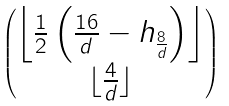<formula> <loc_0><loc_0><loc_500><loc_500>\begin{pmatrix} \left \lfloor \frac { 1 } { 2 } \left ( \frac { 1 6 } { d } - h _ { \frac { 8 } { d } } \right ) \right \rfloor \\ \lfloor \frac { 4 } { d } \rfloor \end{pmatrix}</formula> 